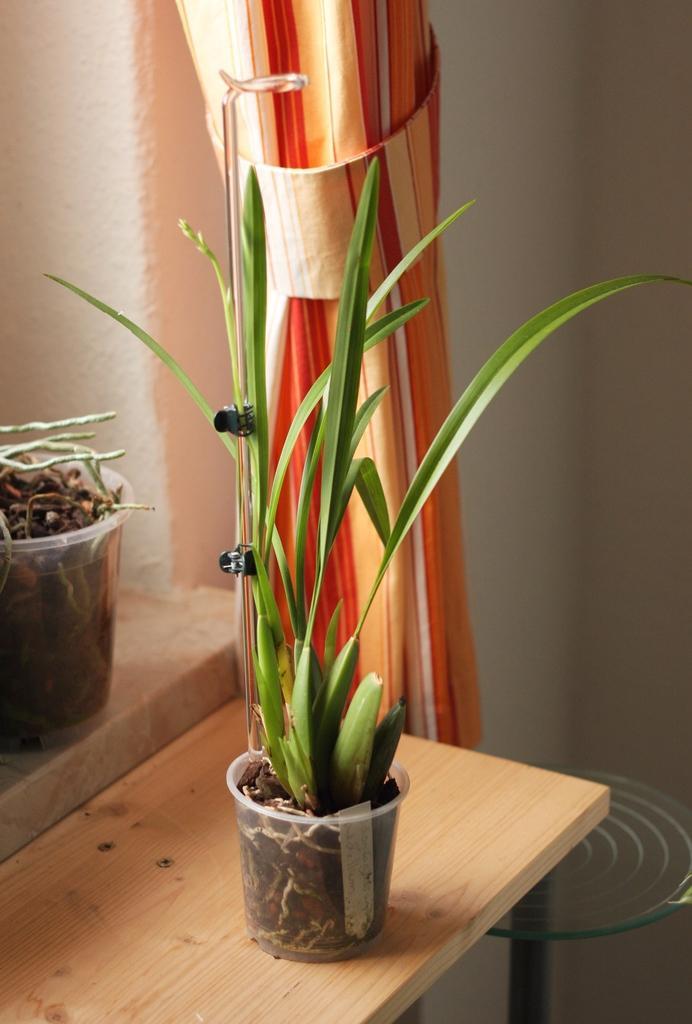Can you describe this image briefly? In this image in the center there is a wooden board, on the board there is a jug and in the jug there is some mud and plant. And in the background there is curtain and wall, and on the right side of the image there is one glass coil. And on the left side there is one jug, in the jug there is mud and plant. 